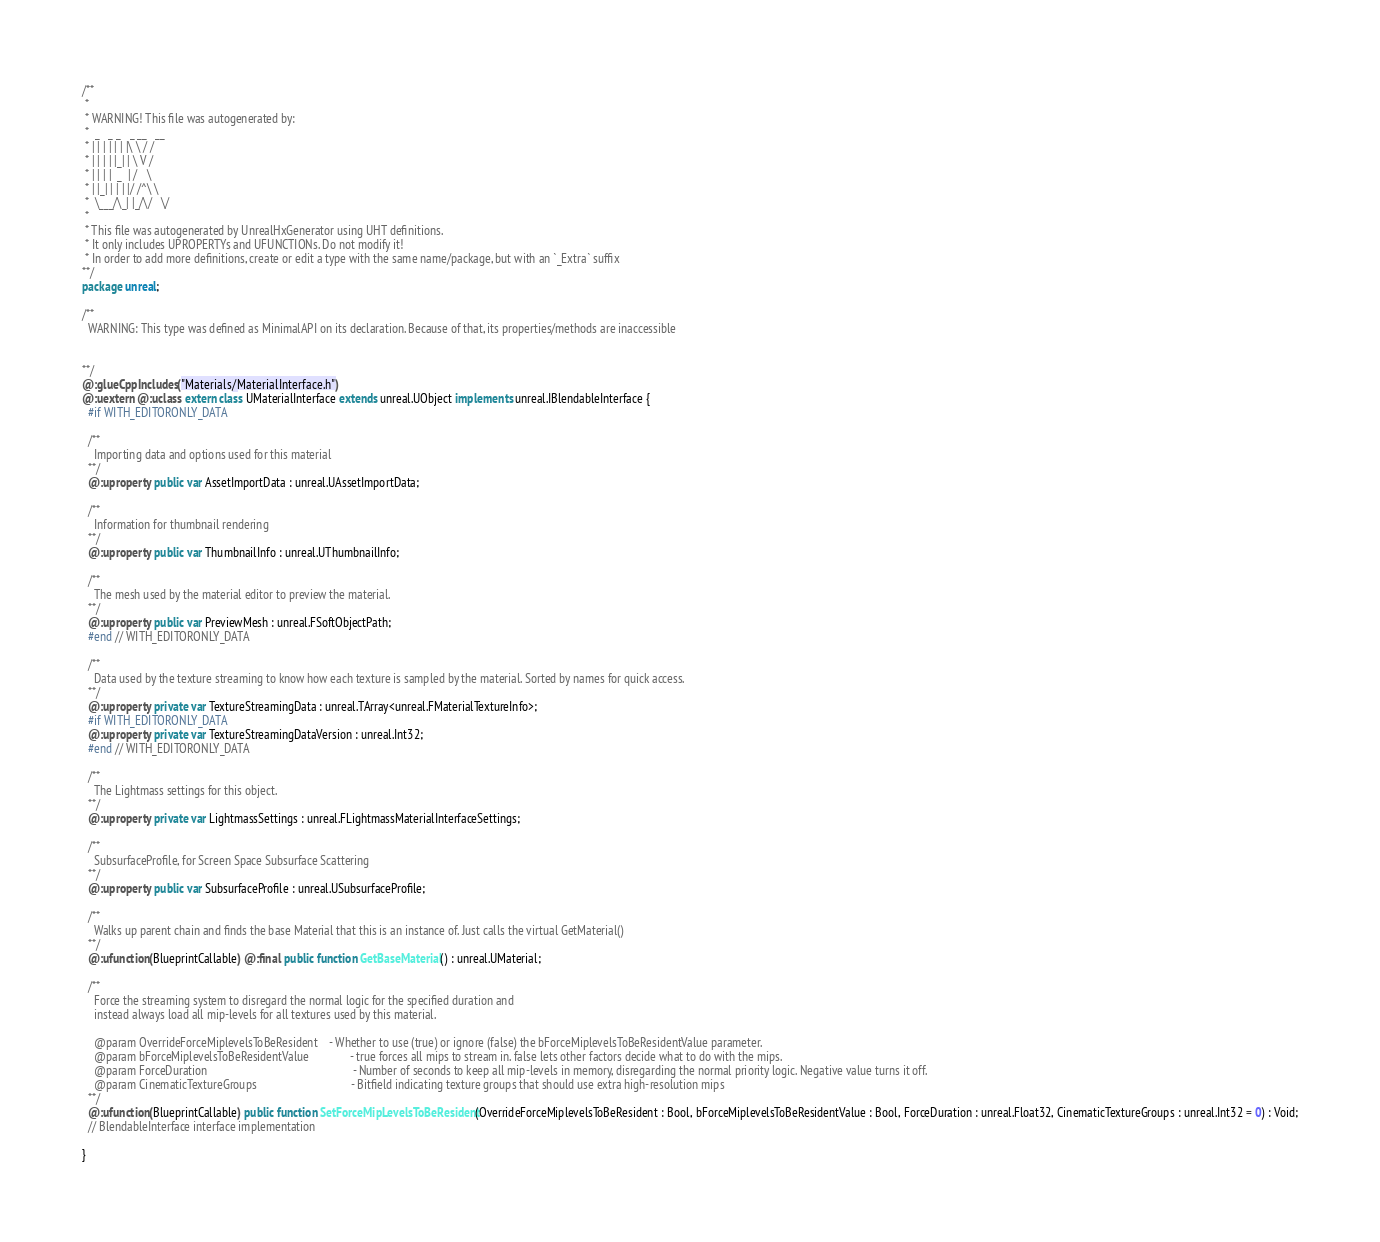<code> <loc_0><loc_0><loc_500><loc_500><_Haxe_>/**
 * 
 * WARNING! This file was autogenerated by: 
 *  _   _ _   _ __   __ 
 * | | | | | | |\ \ / / 
 * | | | | |_| | \ V /  
 * | | | |  _  | /   \  
 * | |_| | | | |/ /^\ \ 
 *  \___/\_| |_/\/   \/ 
 * 
 * This file was autogenerated by UnrealHxGenerator using UHT definitions.
 * It only includes UPROPERTYs and UFUNCTIONs. Do not modify it!
 * In order to add more definitions, create or edit a type with the same name/package, but with an `_Extra` suffix
**/
package unreal;

/**
  WARNING: This type was defined as MinimalAPI on its declaration. Because of that, its properties/methods are inaccessible
  
  
**/
@:glueCppIncludes("Materials/MaterialInterface.h")
@:uextern @:uclass extern class UMaterialInterface extends unreal.UObject implements unreal.IBlendableInterface {
  #if WITH_EDITORONLY_DATA
  
  /**
    Importing data and options used for this material
  **/
  @:uproperty public var AssetImportData : unreal.UAssetImportData;
  
  /**
    Information for thumbnail rendering
  **/
  @:uproperty public var ThumbnailInfo : unreal.UThumbnailInfo;
  
  /**
    The mesh used by the material editor to preview the material.
  **/
  @:uproperty public var PreviewMesh : unreal.FSoftObjectPath;
  #end // WITH_EDITORONLY_DATA
  
  /**
    Data used by the texture streaming to know how each texture is sampled by the material. Sorted by names for quick access.
  **/
  @:uproperty private var TextureStreamingData : unreal.TArray<unreal.FMaterialTextureInfo>;
  #if WITH_EDITORONLY_DATA
  @:uproperty private var TextureStreamingDataVersion : unreal.Int32;
  #end // WITH_EDITORONLY_DATA
  
  /**
    The Lightmass settings for this object.
  **/
  @:uproperty private var LightmassSettings : unreal.FLightmassMaterialInterfaceSettings;
  
  /**
    SubsurfaceProfile, for Screen Space Subsurface Scattering
  **/
  @:uproperty public var SubsurfaceProfile : unreal.USubsurfaceProfile;
  
  /**
    Walks up parent chain and finds the base Material that this is an instance of. Just calls the virtual GetMaterial()
  **/
  @:ufunction(BlueprintCallable) @:final public function GetBaseMaterial() : unreal.UMaterial;
  
  /**
    Force the streaming system to disregard the normal logic for the specified duration and
    instead always load all mip-levels for all textures used by this material.
    
    @param OverrideForceMiplevelsToBeResident    - Whether to use (true) or ignore (false) the bForceMiplevelsToBeResidentValue parameter.
    @param bForceMiplevelsToBeResidentValue              - true forces all mips to stream in. false lets other factors decide what to do with the mips.
    @param ForceDuration                                                 - Number of seconds to keep all mip-levels in memory, disregarding the normal priority logic. Negative value turns it off.
    @param CinematicTextureGroups                                - Bitfield indicating texture groups that should use extra high-resolution mips
  **/
  @:ufunction(BlueprintCallable) public function SetForceMipLevelsToBeResident(OverrideForceMiplevelsToBeResident : Bool, bForceMiplevelsToBeResidentValue : Bool, ForceDuration : unreal.Float32, CinematicTextureGroups : unreal.Int32 = 0) : Void;
  // BlendableInterface interface implementation
  
}
</code> 